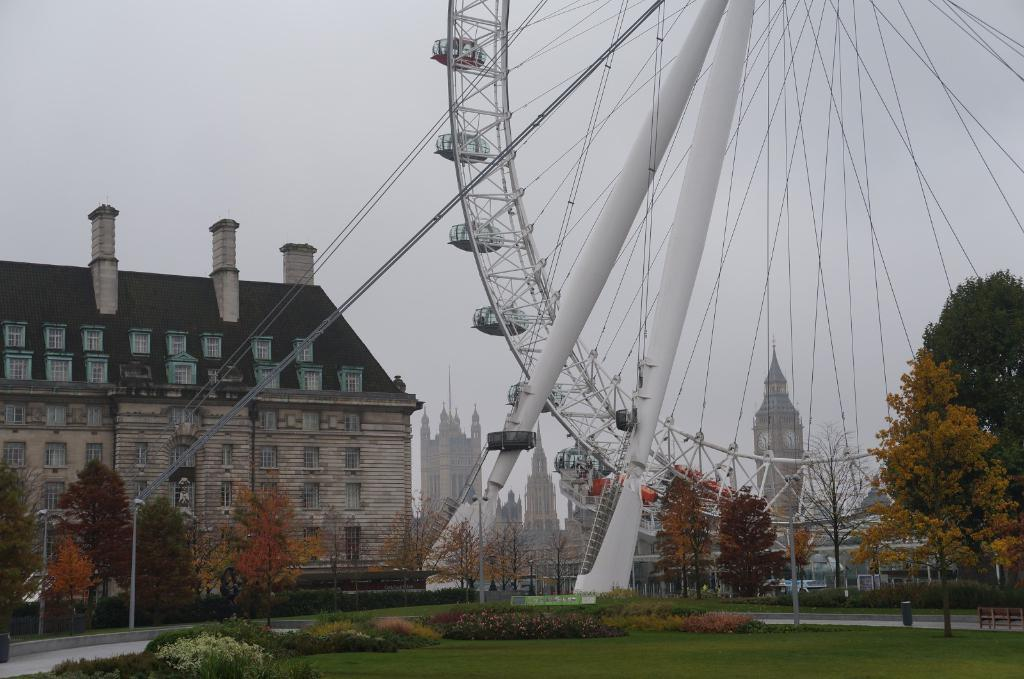What type of vegetation is present in the image? There is grass, plants, and trees in the image. What structures can be seen in the image? There are poles and buildings in the image. What is the unique feature in the image? There is a joint wheel in the image. What can be seen in the background of the image? The sky is visible in the background of the image. What group of servants can be seen working in the image? There are no servants present in the image. What shape does the circle take in the image? There is no circle present in the image. 